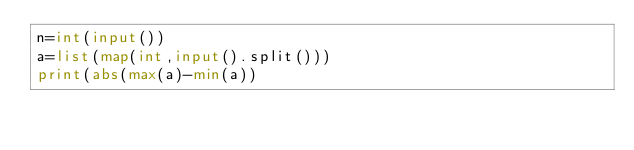Convert code to text. <code><loc_0><loc_0><loc_500><loc_500><_Python_>n=int(input())
a=list(map(int,input().split()))
print(abs(max(a)-min(a))</code> 